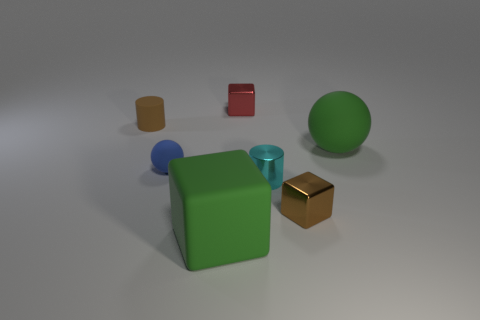What size is the blue ball?
Offer a terse response. Small. What size is the matte ball that is on the left side of the cyan thing?
Make the answer very short. Small. There is a small thing that is both on the right side of the tiny blue matte object and behind the small rubber ball; what is its shape?
Give a very brief answer. Cube. How many other objects are the same shape as the tiny blue matte object?
Provide a short and direct response. 1. There is a ball that is the same size as the cyan metal object; what color is it?
Provide a succinct answer. Blue. How many objects are red cubes or small objects?
Provide a succinct answer. 5. There is a tiny brown metallic block; are there any tiny matte spheres right of it?
Your answer should be very brief. No. Is there a large block made of the same material as the brown cylinder?
Provide a succinct answer. Yes. There is a cube that is the same color as the large rubber ball; what is its size?
Your response must be concise. Large. How many cubes are either small green things or small things?
Ensure brevity in your answer.  2. 